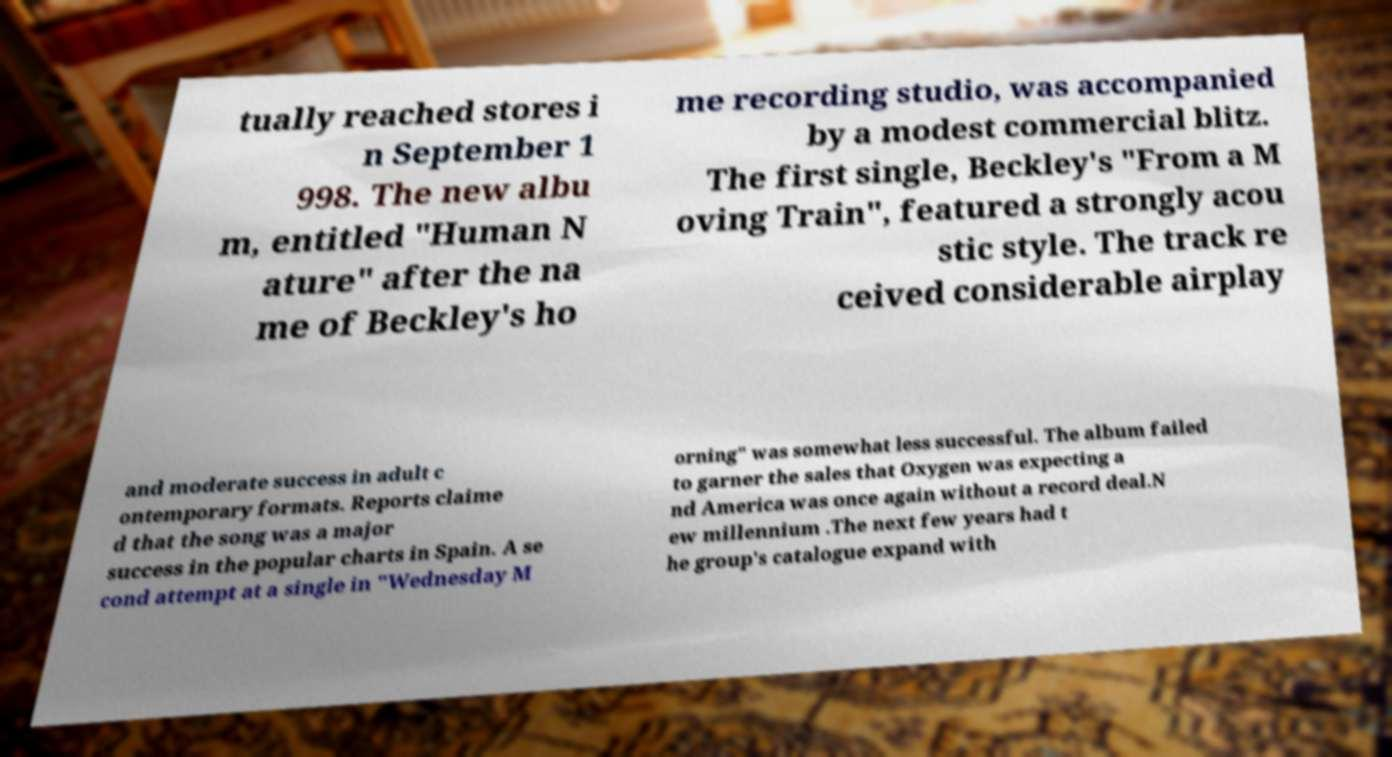Please read and relay the text visible in this image. What does it say? tually reached stores i n September 1 998. The new albu m, entitled "Human N ature" after the na me of Beckley's ho me recording studio, was accompanied by a modest commercial blitz. The first single, Beckley's "From a M oving Train", featured a strongly acou stic style. The track re ceived considerable airplay and moderate success in adult c ontemporary formats. Reports claime d that the song was a major success in the popular charts in Spain. A se cond attempt at a single in "Wednesday M orning" was somewhat less successful. The album failed to garner the sales that Oxygen was expecting a nd America was once again without a record deal.N ew millennium .The next few years had t he group's catalogue expand with 